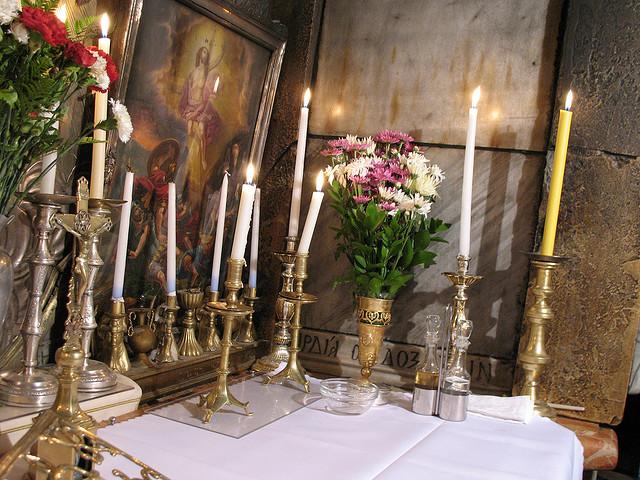Are all the candles lit?
Keep it brief. No. How many candles can you see?
Answer briefly. 11. What type of flowers are in the vases?
Be succinct. Daisies. 